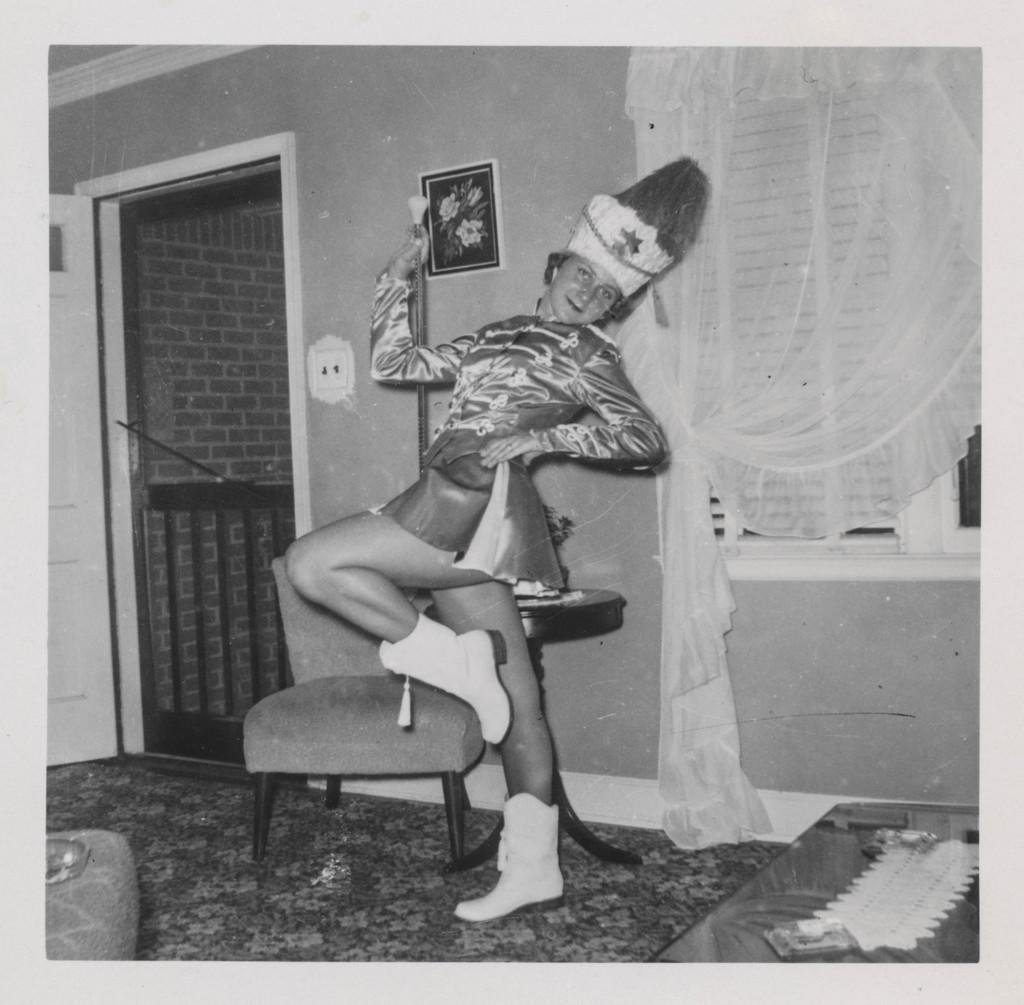Describe this image in one or two sentences. This picture seems to be an edited image with the borders. In the center we can see a person wearing a costume and seems to be dancing and we can see a chair tables and some other items are placed on the ground. In the background we can see the wall, door, picture frame hanging on the wall, curtain, window and window blinds. 